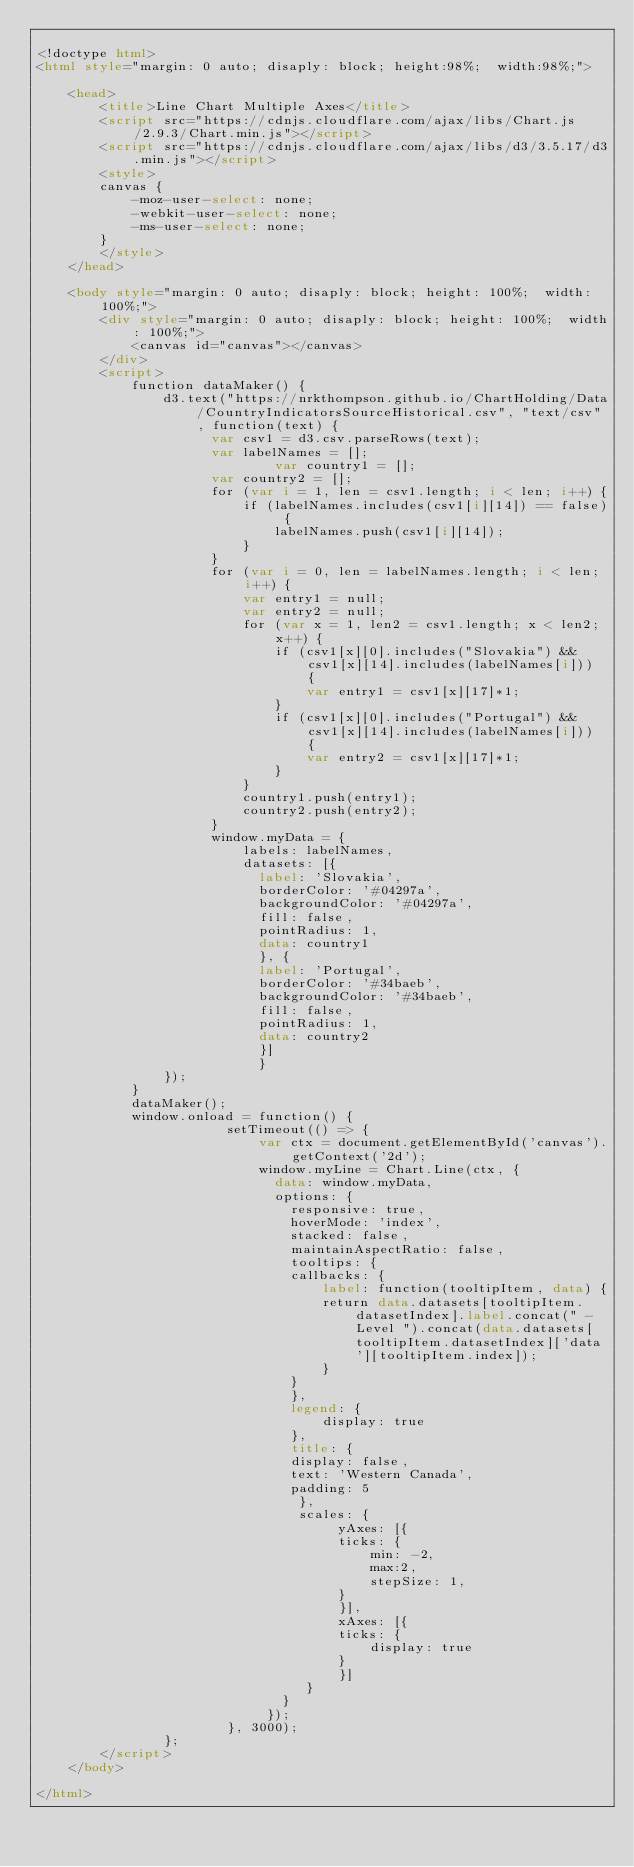Convert code to text. <code><loc_0><loc_0><loc_500><loc_500><_HTML_>
<!doctype html>
<html style="margin: 0 auto; disaply: block; height:98%;  width:98%;">

	<head>
		<title>Line Chart Multiple Axes</title>
		<script src="https://cdnjs.cloudflare.com/ajax/libs/Chart.js/2.9.3/Chart.min.js"></script>
		<script src="https://cdnjs.cloudflare.com/ajax/libs/d3/3.5.17/d3.min.js"></script>
		<style>
		canvas {
			-moz-user-select: none;
			-webkit-user-select: none;
			-ms-user-select: none;
		}
		</style>
	</head>

	<body style="margin: 0 auto; disaply: block; height: 100%;  width: 100%;">
		<div style="margin: 0 auto; disaply: block; height: 100%;  width: 100%;">
			<canvas id="canvas"></canvas>
		</div>
		<script>
			function dataMaker() {
				d3.text("https://nrkthompson.github.io/ChartHolding/Data/CountryIndicatorsSourceHistorical.csv", "text/csv", function(text) {
					  var csv1 = d3.csv.parseRows(text);
					  var labelNames = [];
            				  var country1 = [];
					  var country2 = [];
					  for (var i = 1, len = csv1.length; i < len; i++) {
						  if (labelNames.includes(csv1[i][14]) == false) {
							  labelNames.push(csv1[i][14]);
						  }
					  }
					  for (var i = 0, len = labelNames.length; i < len; i++) {
						  var entry1 = null;
						  var entry2 = null;
						  for (var x = 1, len2 = csv1.length; x < len2; x++) {
							  if (csv1[x][0].includes("Slovakia") && csv1[x][14].includes(labelNames[i])) {
								  var entry1 = csv1[x][17]*1;
							  }
							  if (csv1[x][0].includes("Portugal") && csv1[x][14].includes(labelNames[i])) {
								  var entry2 = csv1[x][17]*1;
							  }
						  }
						  country1.push(entry1);
						  country2.push(entry2);
					  }
					  window.myData = {
						  labels: labelNames,
						  datasets: [{
						    label: 'Slovakia',
						    borderColor: '#04297a',
						    backgroundColor: '#04297a',
						    fill: false,
						    pointRadius: 1,
						    data: country1
						    }, {
						    label: 'Portugal',
						    borderColor: '#34baeb',
						    backgroundColor: '#34baeb',
						    fill: false,
						    pointRadius: 1,
						    data: country2
						    }]
						    }  
				});
			}
			dataMaker();
			window.onload = function() {
						setTimeout(() => { 
							var ctx = document.getElementById('canvas').getContext('2d');
							window.myLine = Chart.Line(ctx, {
							  data: window.myData,
							  options: {
							    responsive: true,
							    hoverMode: 'index',
							    stacked: false,
							    maintainAspectRatio: false,
							    tooltips: {
								callbacks: {
								    label: function(tooltipItem, data) {
									return data.datasets[tooltipItem.datasetIndex].label.concat(" - Level ").concat(data.datasets[tooltipItem.datasetIndex]['data'][tooltipItem.index]);
								    }
								}
							    },
							    legend: {
								    display: true
							    },
							    title: {
								display: false,
								text: 'Western Canada',
								padding: 5
							     },
							     scales: {
								      yAxes: [{
									  ticks: {
									      min: -2,
									      max:2,
									      stepSize: 1,
									  }
								      }],
								      xAxes: [{
									  ticks: {
									      display: true
									  }
								      }]
								  }
							   }
							 });
						}, 3000);
				};
		</script>
	</body>

</html></code> 